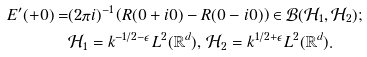Convert formula to latex. <formula><loc_0><loc_0><loc_500><loc_500>E ^ { \prime } ( + 0 ) = & ( 2 \pi i ) ^ { - 1 } \left ( R ( 0 + i 0 ) - R ( 0 - i 0 ) \right ) \in { \mathcal { B } } ( { \mathcal { H } } _ { 1 } , { \mathcal { H } } _ { 2 } ) ; \\ & { \mathcal { H } } _ { 1 } = k ^ { - 1 / 2 - \epsilon } L ^ { 2 } ( { \mathbb { R } } ^ { d } ) , \, { \mathcal { H } } _ { 2 } = k ^ { 1 / 2 + \epsilon } L ^ { 2 } ( { \mathbb { R } } ^ { d } ) .</formula> 